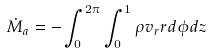<formula> <loc_0><loc_0><loc_500><loc_500>\dot { M } _ { a } = - \int _ { 0 } ^ { 2 \pi } \int _ { 0 } ^ { 1 } \rho v _ { r } r d \phi d z</formula> 